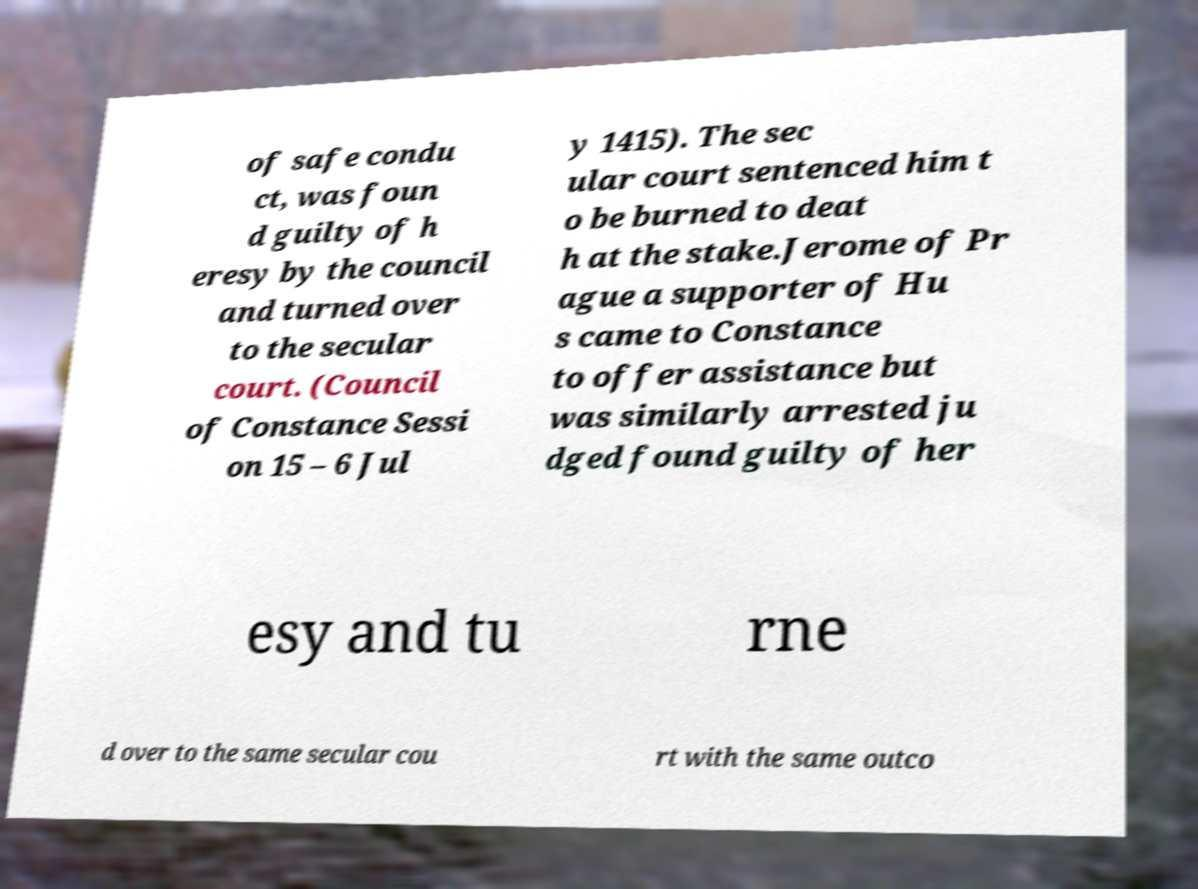Could you assist in decoding the text presented in this image and type it out clearly? of safe condu ct, was foun d guilty of h eresy by the council and turned over to the secular court. (Council of Constance Sessi on 15 – 6 Jul y 1415). The sec ular court sentenced him t o be burned to deat h at the stake.Jerome of Pr ague a supporter of Hu s came to Constance to offer assistance but was similarly arrested ju dged found guilty of her esy and tu rne d over to the same secular cou rt with the same outco 